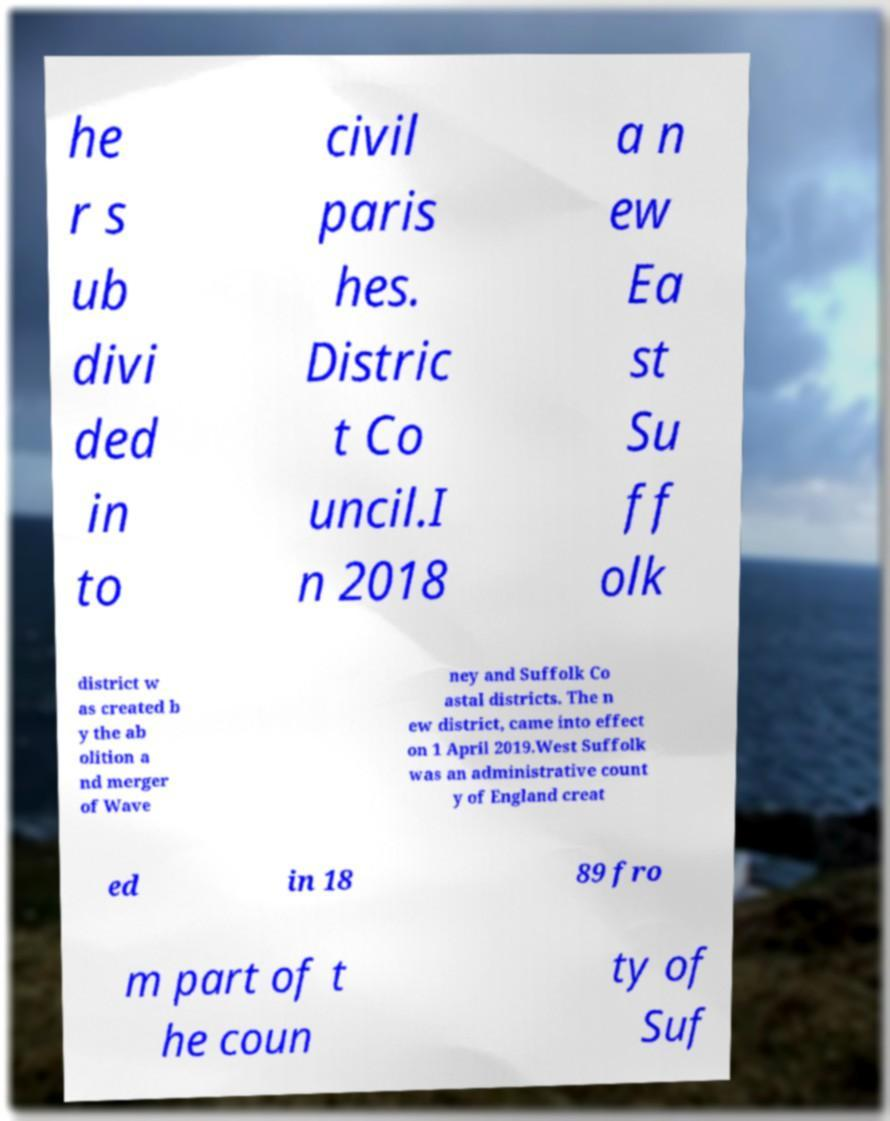For documentation purposes, I need the text within this image transcribed. Could you provide that? he r s ub divi ded in to civil paris hes. Distric t Co uncil.I n 2018 a n ew Ea st Su ff olk district w as created b y the ab olition a nd merger of Wave ney and Suffolk Co astal districts. The n ew district, came into effect on 1 April 2019.West Suffolk was an administrative count y of England creat ed in 18 89 fro m part of t he coun ty of Suf 